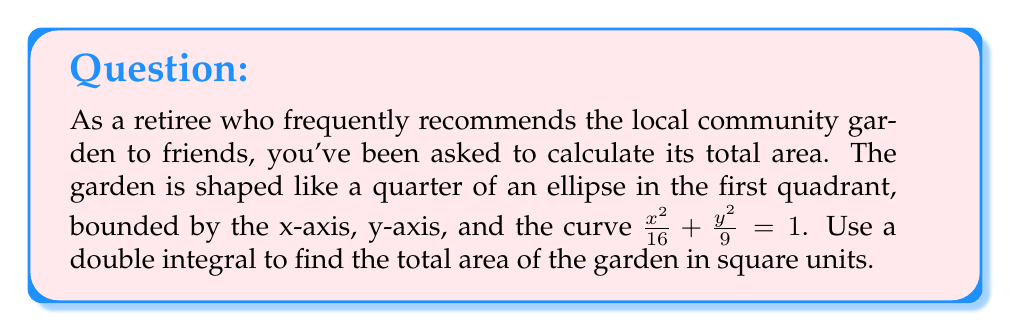Help me with this question. To find the area of the quarter ellipse using a double integral, we'll follow these steps:

1) The equation of the ellipse is $\frac{x^2}{16} + \frac{y^2}{9} = 1$. We need to solve this for y:

   $\frac{y^2}{9} = 1 - \frac{x^2}{16}$
   $y^2 = 9(1 - \frac{x^2}{16}) = 9 - \frac{9x^2}{16}$
   $y = \pm \sqrt{9 - \frac{9x^2}{16}}$

   Since we're in the first quadrant, we'll use the positive root.

2) The limits of integration for x will be from 0 to 4 (the x-intercept of the ellipse).

3) For y, the lower limit will be 0, and the upper limit will be our solved equation for y.

4) Our double integral will be:

   $$A = \int_0^4 \int_0^{\sqrt{9 - \frac{9x^2}{16}}} dy dx$$

5) Integrating with respect to y first:

   $$A = \int_0^4 \left[y\right]_0^{\sqrt{9 - \frac{9x^2}{16}}} dx = \int_0^4 \sqrt{9 - \frac{9x^2}{16}} dx$$

6) This integral is in the form $\int \sqrt{a^2 - b^2x^2} dx$, which has the solution:

   $\frac{a^2}{2b} \arcsin(\frac{bx}{a}) + \frac{x}{2}\sqrt{a^2 - b^2x^2} + C$

   Here, $a^2 = 9$ and $b^2 = \frac{9}{16}$

7) Applying this solution:

   $$A = \left[\frac{9}{2\frac{3}{4}} \arcsin(\frac{3x}{4}) + \frac{x}{2}\sqrt{9 - \frac{9x^2}{16}}\right]_0^4$$

8) Evaluating at the limits:

   $$A = \left[6 \arcsin(\frac{3}{4}) + 0\right] - \left[6 \arcsin(0) + 0\right]$$

9) $\arcsin(\frac{3}{4}) = \frac{\pi}{3}$ and $\arcsin(0) = 0$, so:

   $$A = 6 \cdot \frac{\pi}{3} = 2\pi$$

Therefore, the area of the community garden is $2\pi$ square units.
Answer: $2\pi$ square units 